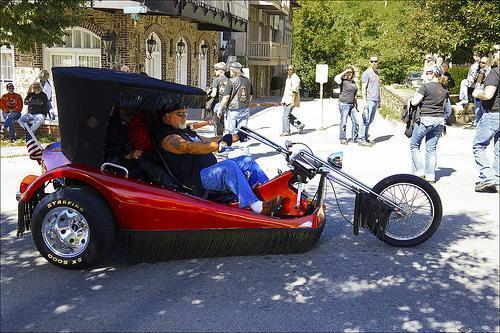How many yellow letters are there?
Give a very brief answer. 14. 